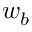<formula> <loc_0><loc_0><loc_500><loc_500>w _ { b }</formula> 